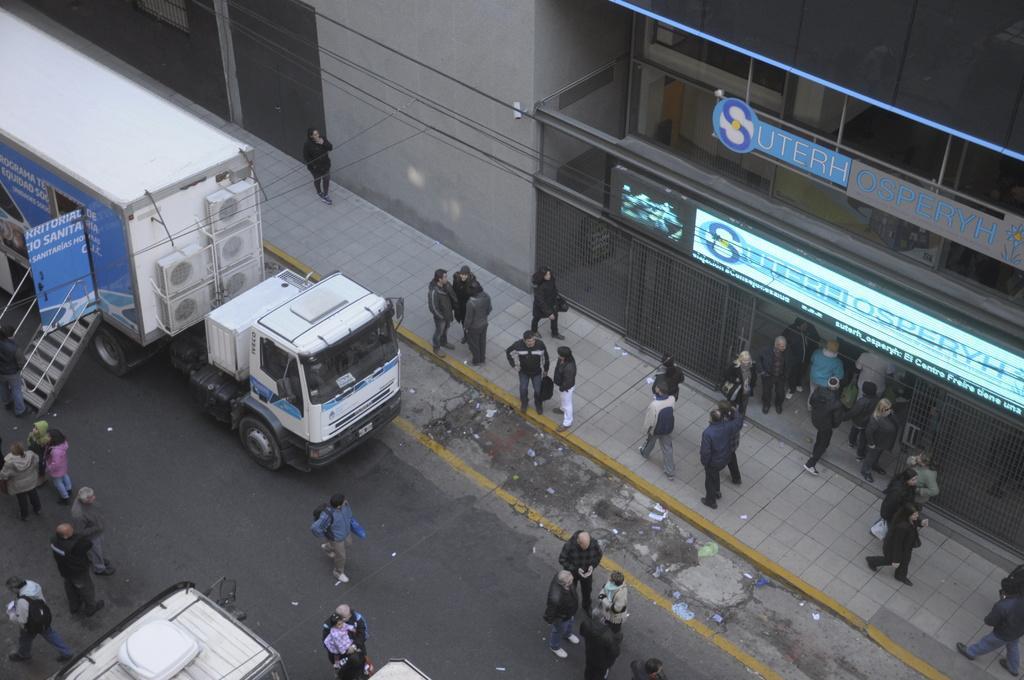In one or two sentences, can you explain what this image depicts? Here we can see vehicles and few persons. There are boards. In the background we can see a building. 